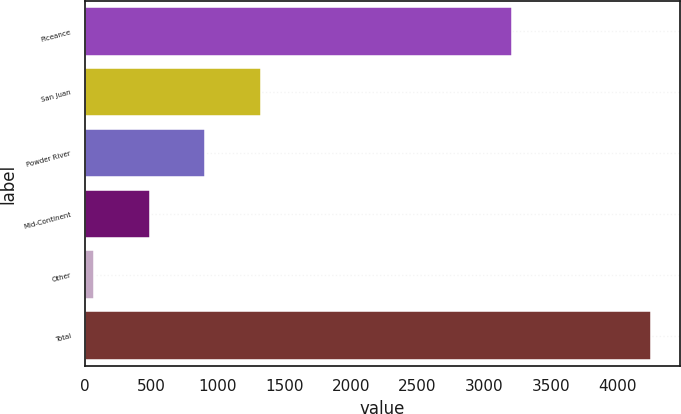<chart> <loc_0><loc_0><loc_500><loc_500><bar_chart><fcel>Piceance<fcel>San Juan<fcel>Powder River<fcel>Mid-Continent<fcel>Other<fcel>Total<nl><fcel>3207<fcel>1323.4<fcel>904.6<fcel>485.8<fcel>67<fcel>4255<nl></chart> 